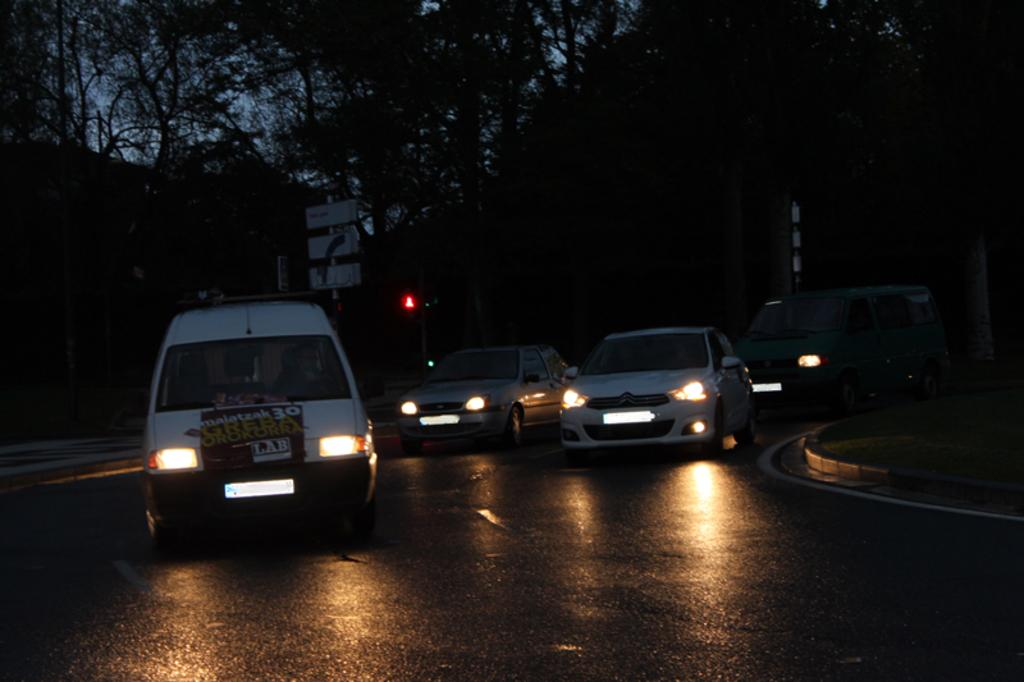What is happening on the road in the image? There are vehicles moving on the road in the image. What type of natural scenery can be seen in the image? Trees are visible at the top of the image. Who is the creator of the room visible in the image? There is no room visible in the image; it only features vehicles moving on the road and trees at the top. 